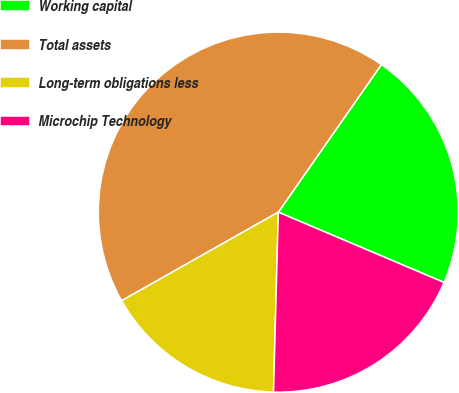Convert chart to OTSL. <chart><loc_0><loc_0><loc_500><loc_500><pie_chart><fcel>Working capital<fcel>Total assets<fcel>Long-term obligations less<fcel>Microchip Technology<nl><fcel>21.69%<fcel>42.89%<fcel>16.39%<fcel>19.04%<nl></chart> 